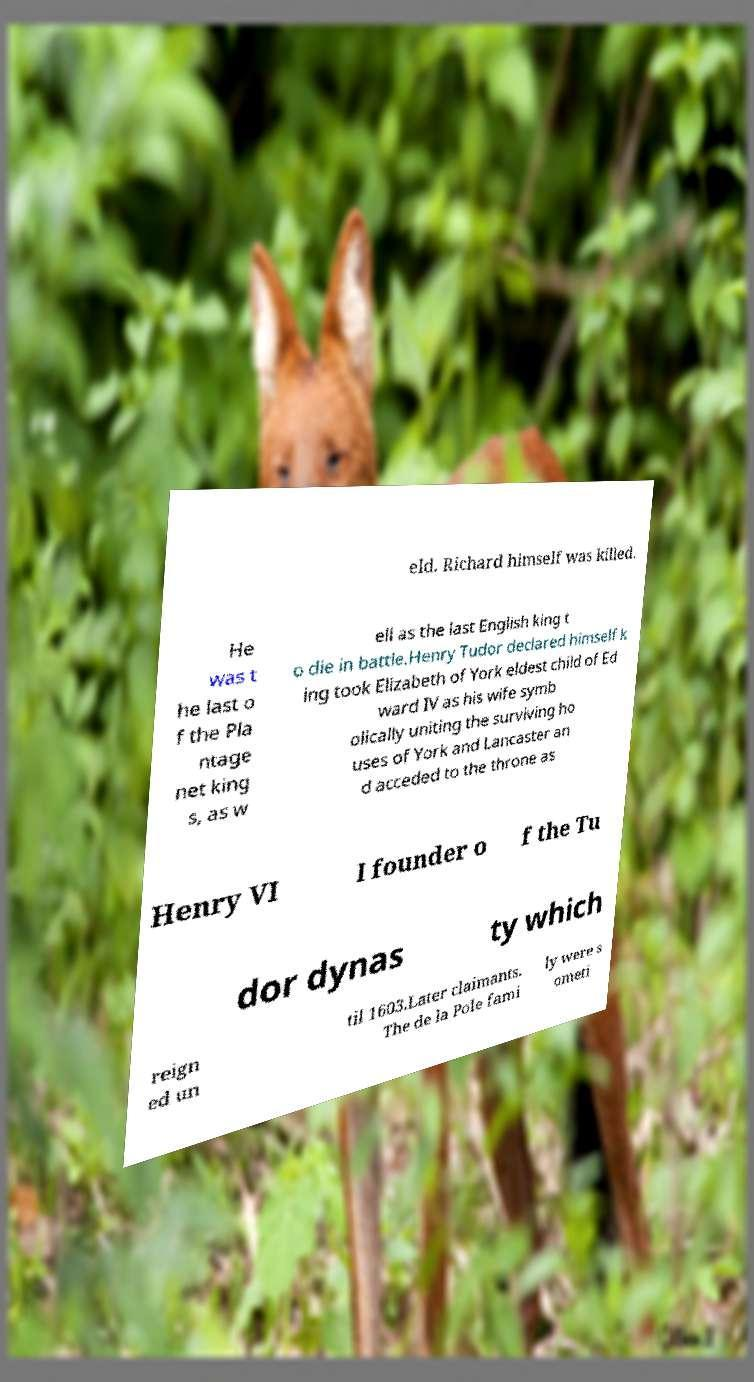Could you assist in decoding the text presented in this image and type it out clearly? eld. Richard himself was killed. He was t he last o f the Pla ntage net king s, as w ell as the last English king t o die in battle.Henry Tudor declared himself k ing took Elizabeth of York eldest child of Ed ward IV as his wife symb olically uniting the surviving ho uses of York and Lancaster an d acceded to the throne as Henry VI I founder o f the Tu dor dynas ty which reign ed un til 1603.Later claimants. The de la Pole fami ly were s ometi 